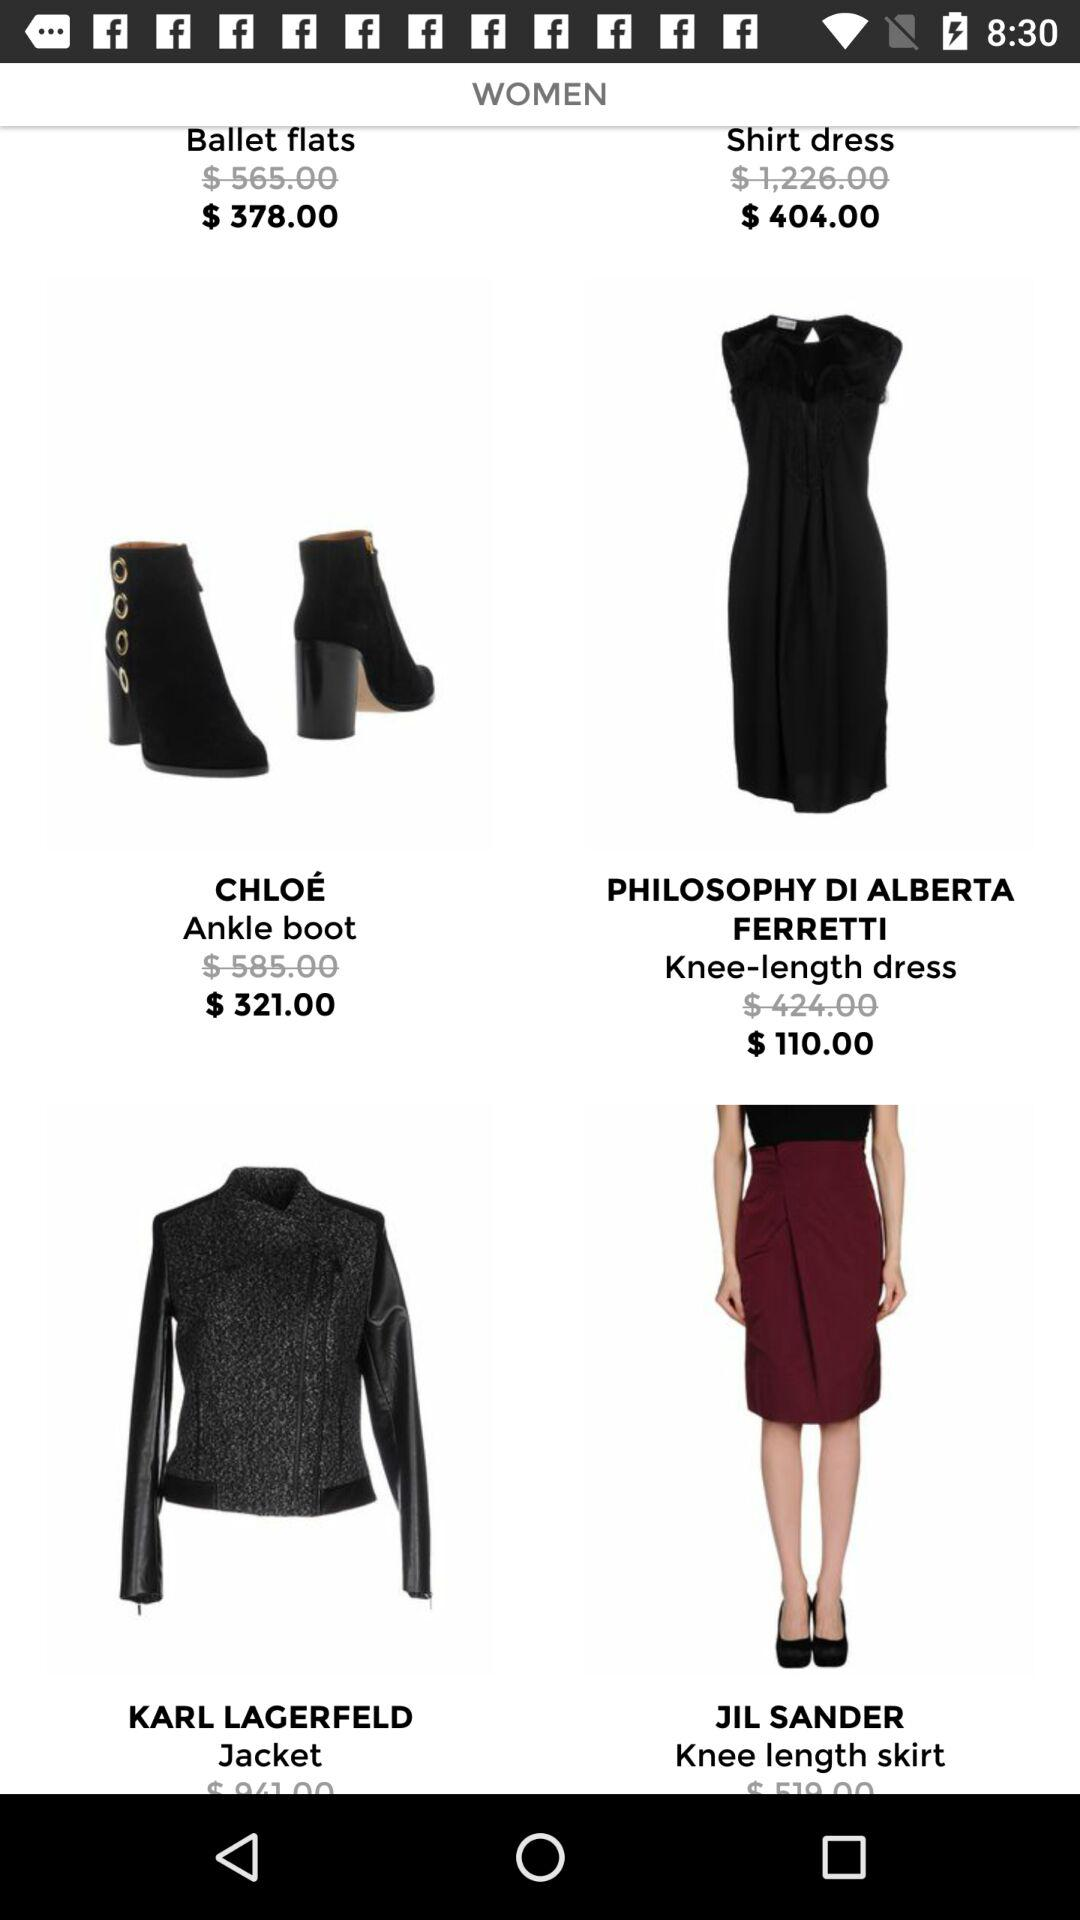What is the after-discount price of a dress? The after-discount price of a dress is $110.00. 